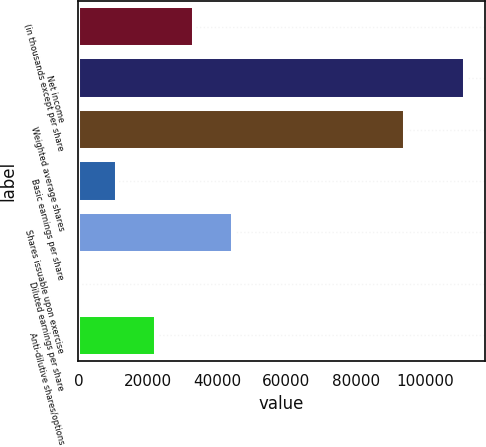<chart> <loc_0><loc_0><loc_500><loc_500><bar_chart><fcel>(in thousands except per share<fcel>Net income<fcel>Weighted average shares<fcel>Basic earnings per share<fcel>Shares issuable upon exercise<fcel>Diluted earnings per share<fcel>Anti-dilutive shares/options<nl><fcel>33502.2<fcel>111671<fcel>94142<fcel>11168.3<fcel>44669.2<fcel>1.29<fcel>22335.2<nl></chart> 